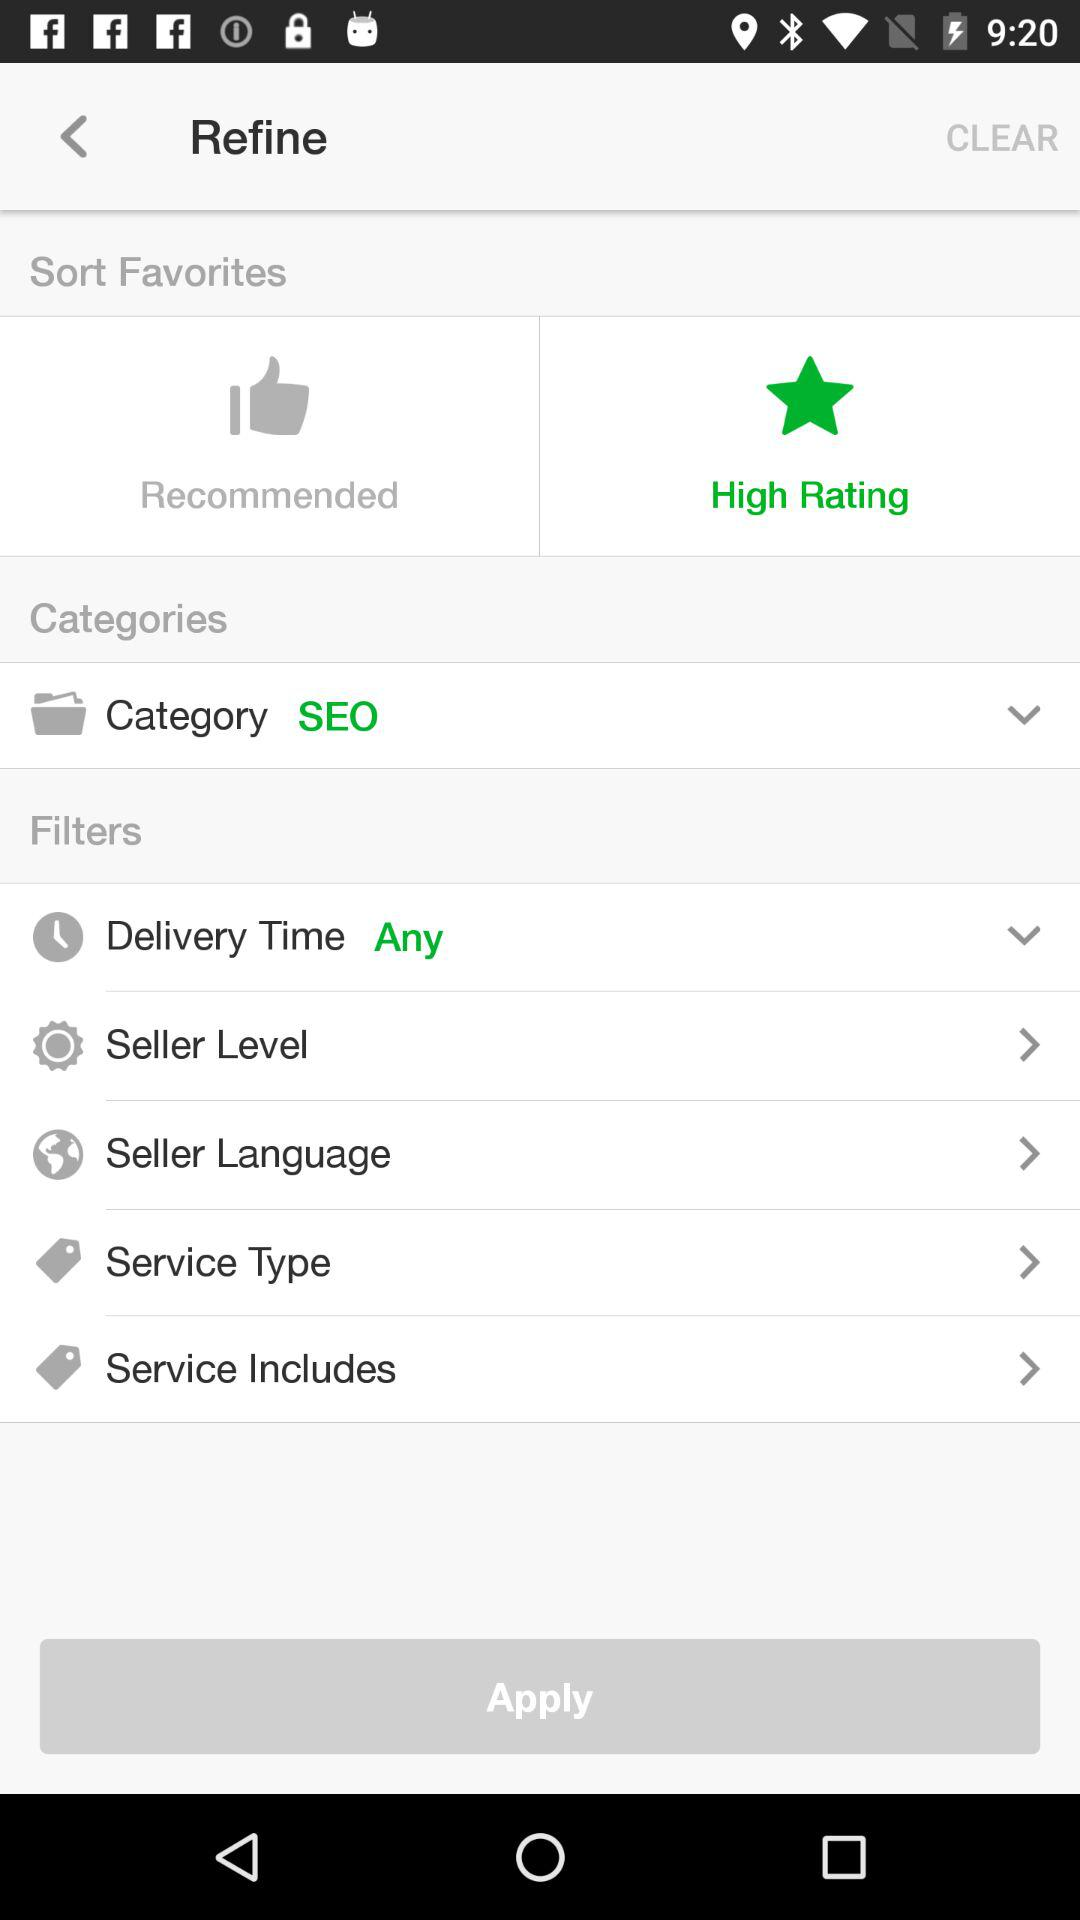What is the selected category? The selected category is "SEO". 